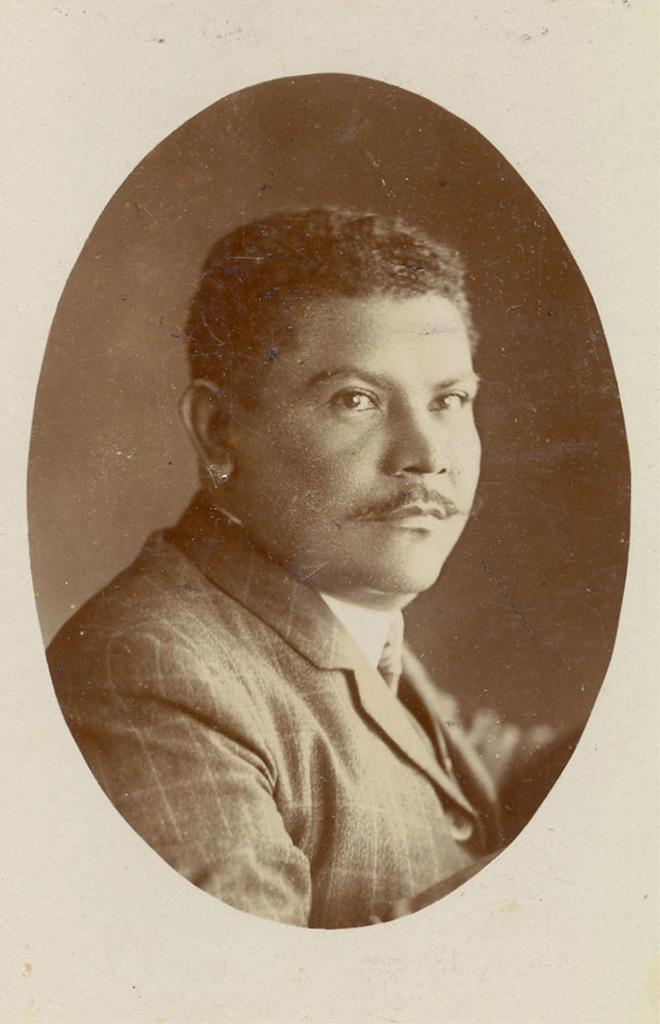Who or what is in the image? There is a person in the image. Can you describe the person's position in relation to the image? The person is in front. What is visible behind the person? There is a wall behind the person. How many fingers does the person have in the image? The number of fingers the person has cannot be determined from the image, as their hands are not visible. 